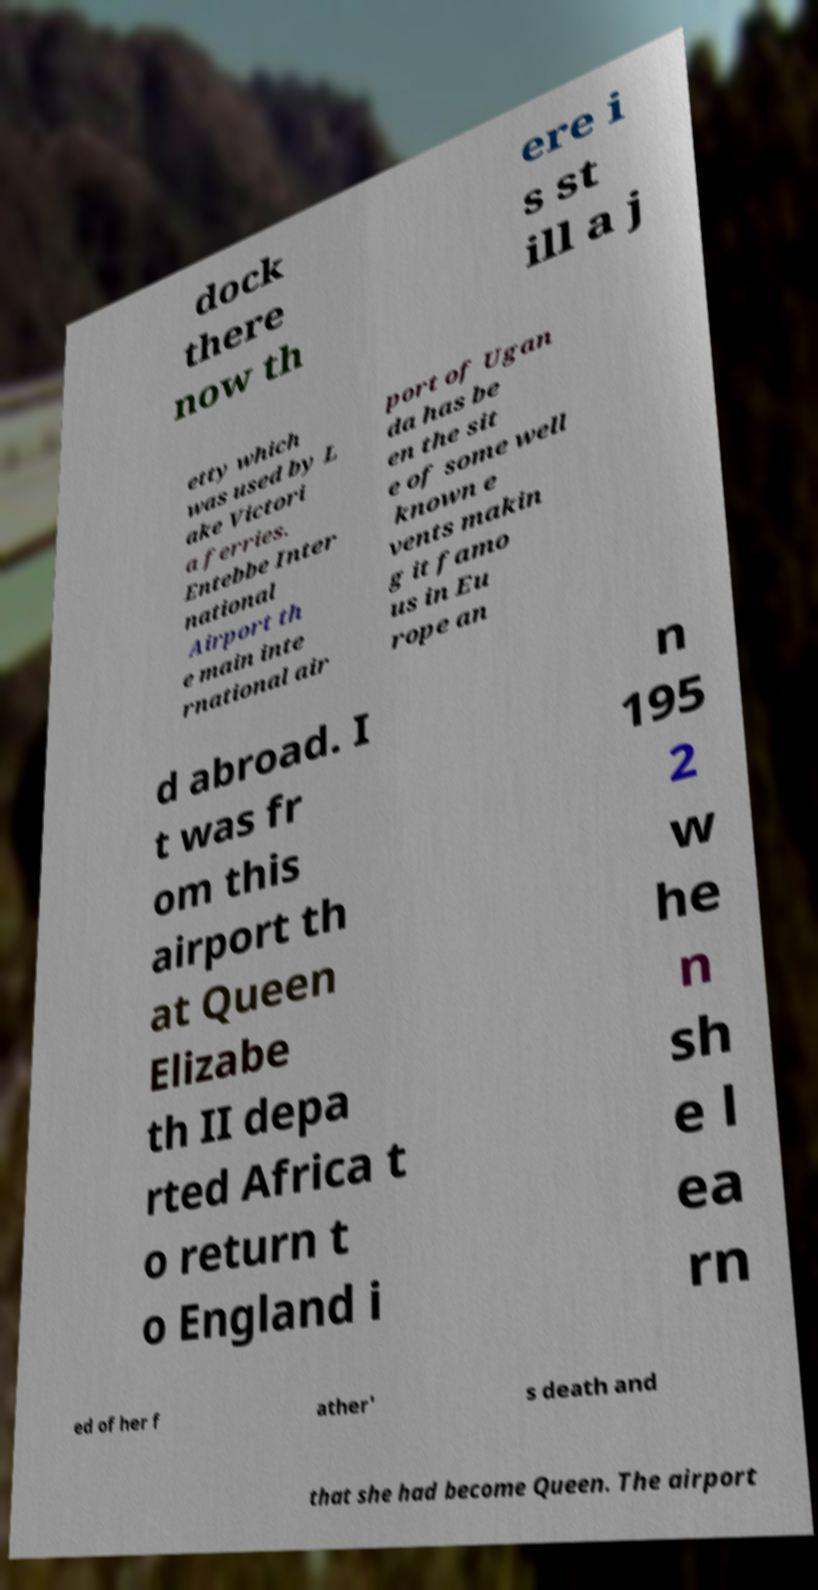There's text embedded in this image that I need extracted. Can you transcribe it verbatim? dock there now th ere i s st ill a j etty which was used by L ake Victori a ferries. Entebbe Inter national Airport th e main inte rnational air port of Ugan da has be en the sit e of some well known e vents makin g it famo us in Eu rope an d abroad. I t was fr om this airport th at Queen Elizabe th II depa rted Africa t o return t o England i n 195 2 w he n sh e l ea rn ed of her f ather' s death and that she had become Queen. The airport 